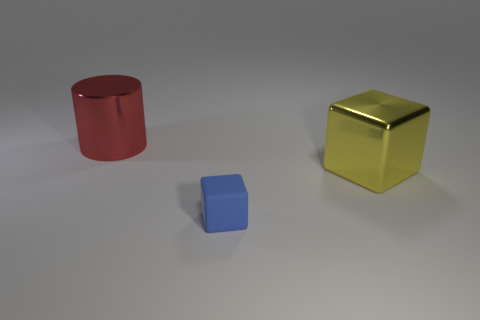Add 2 tiny blue rubber cubes. How many objects exist? 5 Subtract all cylinders. How many objects are left? 2 Add 2 blue cubes. How many blue cubes are left? 3 Add 3 red metallic things. How many red metallic things exist? 4 Subtract 0 brown cylinders. How many objects are left? 3 Subtract all blue matte objects. Subtract all large things. How many objects are left? 0 